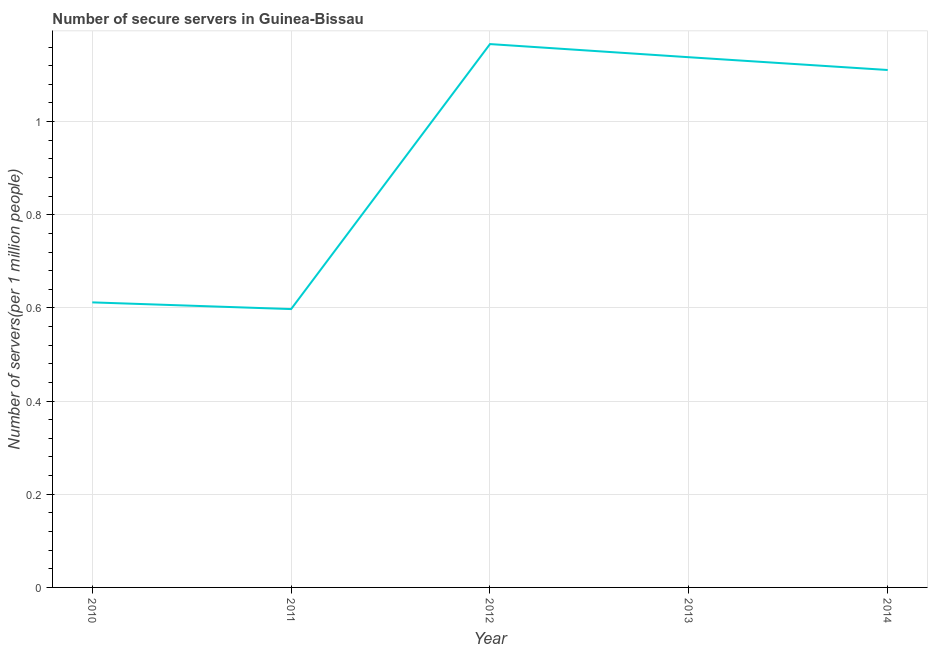What is the number of secure internet servers in 2012?
Your answer should be very brief. 1.17. Across all years, what is the maximum number of secure internet servers?
Provide a succinct answer. 1.17. Across all years, what is the minimum number of secure internet servers?
Make the answer very short. 0.6. In which year was the number of secure internet servers maximum?
Your answer should be compact. 2012. What is the sum of the number of secure internet servers?
Provide a succinct answer. 4.62. What is the difference between the number of secure internet servers in 2010 and 2011?
Ensure brevity in your answer.  0.01. What is the average number of secure internet servers per year?
Your answer should be very brief. 0.92. What is the median number of secure internet servers?
Ensure brevity in your answer.  1.11. In how many years, is the number of secure internet servers greater than 0.6000000000000001 ?
Offer a very short reply. 4. What is the ratio of the number of secure internet servers in 2011 to that in 2013?
Provide a succinct answer. 0.52. Is the number of secure internet servers in 2011 less than that in 2013?
Ensure brevity in your answer.  Yes. What is the difference between the highest and the second highest number of secure internet servers?
Keep it short and to the point. 0.03. Is the sum of the number of secure internet servers in 2011 and 2014 greater than the maximum number of secure internet servers across all years?
Offer a terse response. Yes. What is the difference between the highest and the lowest number of secure internet servers?
Provide a succinct answer. 0.57. How many lines are there?
Ensure brevity in your answer.  1. How many years are there in the graph?
Your answer should be very brief. 5. Does the graph contain grids?
Your response must be concise. Yes. What is the title of the graph?
Give a very brief answer. Number of secure servers in Guinea-Bissau. What is the label or title of the Y-axis?
Offer a very short reply. Number of servers(per 1 million people). What is the Number of servers(per 1 million people) in 2010?
Make the answer very short. 0.61. What is the Number of servers(per 1 million people) in 2011?
Your response must be concise. 0.6. What is the Number of servers(per 1 million people) in 2012?
Give a very brief answer. 1.17. What is the Number of servers(per 1 million people) of 2013?
Give a very brief answer. 1.14. What is the Number of servers(per 1 million people) of 2014?
Ensure brevity in your answer.  1.11. What is the difference between the Number of servers(per 1 million people) in 2010 and 2011?
Provide a succinct answer. 0.01. What is the difference between the Number of servers(per 1 million people) in 2010 and 2012?
Give a very brief answer. -0.55. What is the difference between the Number of servers(per 1 million people) in 2010 and 2013?
Your answer should be very brief. -0.53. What is the difference between the Number of servers(per 1 million people) in 2010 and 2014?
Keep it short and to the point. -0.5. What is the difference between the Number of servers(per 1 million people) in 2011 and 2012?
Your response must be concise. -0.57. What is the difference between the Number of servers(per 1 million people) in 2011 and 2013?
Provide a short and direct response. -0.54. What is the difference between the Number of servers(per 1 million people) in 2011 and 2014?
Ensure brevity in your answer.  -0.51. What is the difference between the Number of servers(per 1 million people) in 2012 and 2013?
Provide a succinct answer. 0.03. What is the difference between the Number of servers(per 1 million people) in 2012 and 2014?
Your response must be concise. 0.06. What is the difference between the Number of servers(per 1 million people) in 2013 and 2014?
Your response must be concise. 0.03. What is the ratio of the Number of servers(per 1 million people) in 2010 to that in 2012?
Keep it short and to the point. 0.53. What is the ratio of the Number of servers(per 1 million people) in 2010 to that in 2013?
Provide a succinct answer. 0.54. What is the ratio of the Number of servers(per 1 million people) in 2010 to that in 2014?
Offer a terse response. 0.55. What is the ratio of the Number of servers(per 1 million people) in 2011 to that in 2012?
Provide a short and direct response. 0.51. What is the ratio of the Number of servers(per 1 million people) in 2011 to that in 2013?
Your answer should be compact. 0.53. What is the ratio of the Number of servers(per 1 million people) in 2011 to that in 2014?
Offer a terse response. 0.54. 